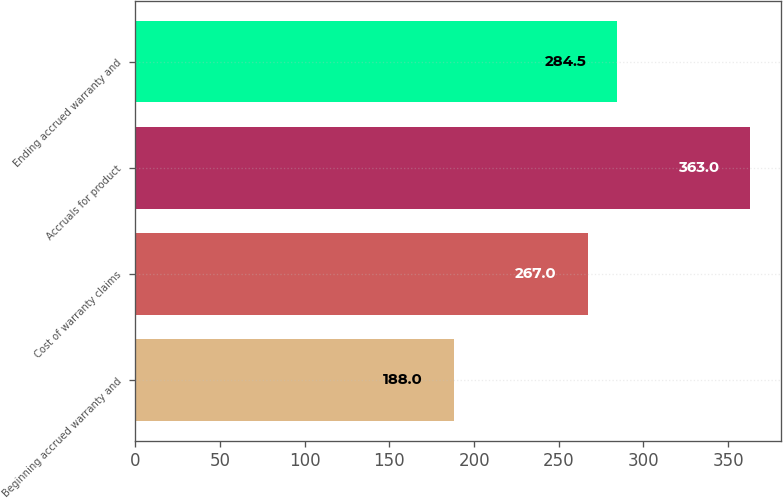<chart> <loc_0><loc_0><loc_500><loc_500><bar_chart><fcel>Beginning accrued warranty and<fcel>Cost of warranty claims<fcel>Accruals for product<fcel>Ending accrued warranty and<nl><fcel>188<fcel>267<fcel>363<fcel>284.5<nl></chart> 